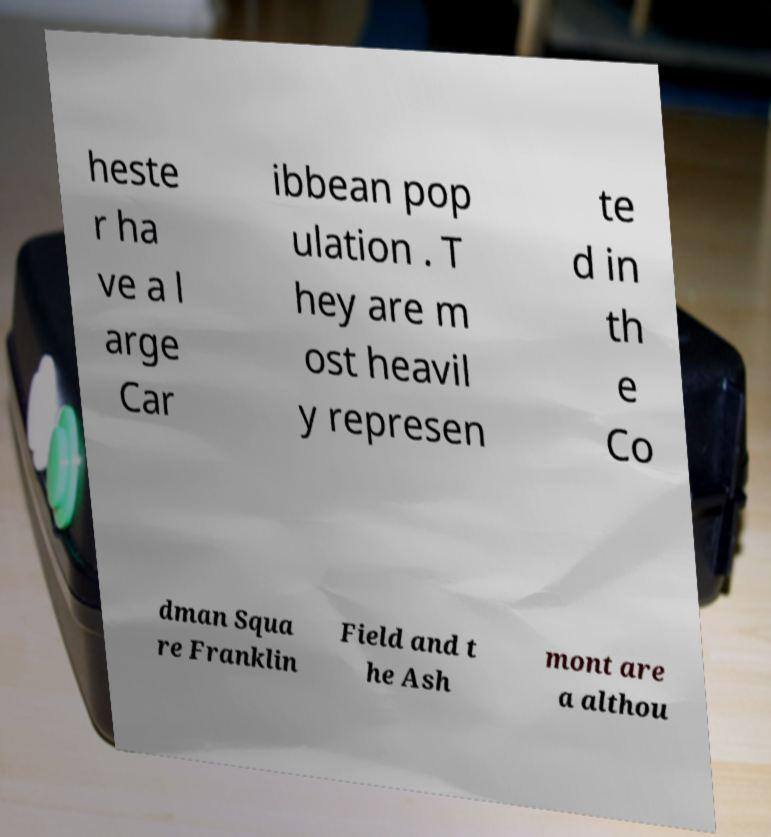Can you accurately transcribe the text from the provided image for me? heste r ha ve a l arge Car ibbean pop ulation . T hey are m ost heavil y represen te d in th e Co dman Squa re Franklin Field and t he Ash mont are a althou 